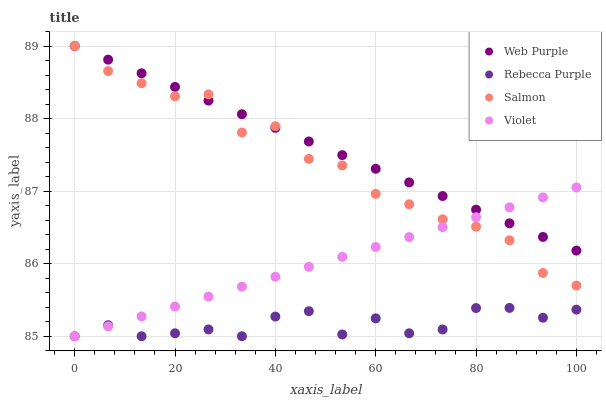Does Rebecca Purple have the minimum area under the curve?
Answer yes or no. Yes. Does Web Purple have the maximum area under the curve?
Answer yes or no. Yes. Does Salmon have the minimum area under the curve?
Answer yes or no. No. Does Salmon have the maximum area under the curve?
Answer yes or no. No. Is Violet the smoothest?
Answer yes or no. Yes. Is Salmon the roughest?
Answer yes or no. Yes. Is Rebecca Purple the smoothest?
Answer yes or no. No. Is Rebecca Purple the roughest?
Answer yes or no. No. Does Rebecca Purple have the lowest value?
Answer yes or no. Yes. Does Salmon have the lowest value?
Answer yes or no. No. Does Salmon have the highest value?
Answer yes or no. Yes. Does Rebecca Purple have the highest value?
Answer yes or no. No. Is Rebecca Purple less than Salmon?
Answer yes or no. Yes. Is Web Purple greater than Rebecca Purple?
Answer yes or no. Yes. Does Violet intersect Web Purple?
Answer yes or no. Yes. Is Violet less than Web Purple?
Answer yes or no. No. Is Violet greater than Web Purple?
Answer yes or no. No. Does Rebecca Purple intersect Salmon?
Answer yes or no. No. 